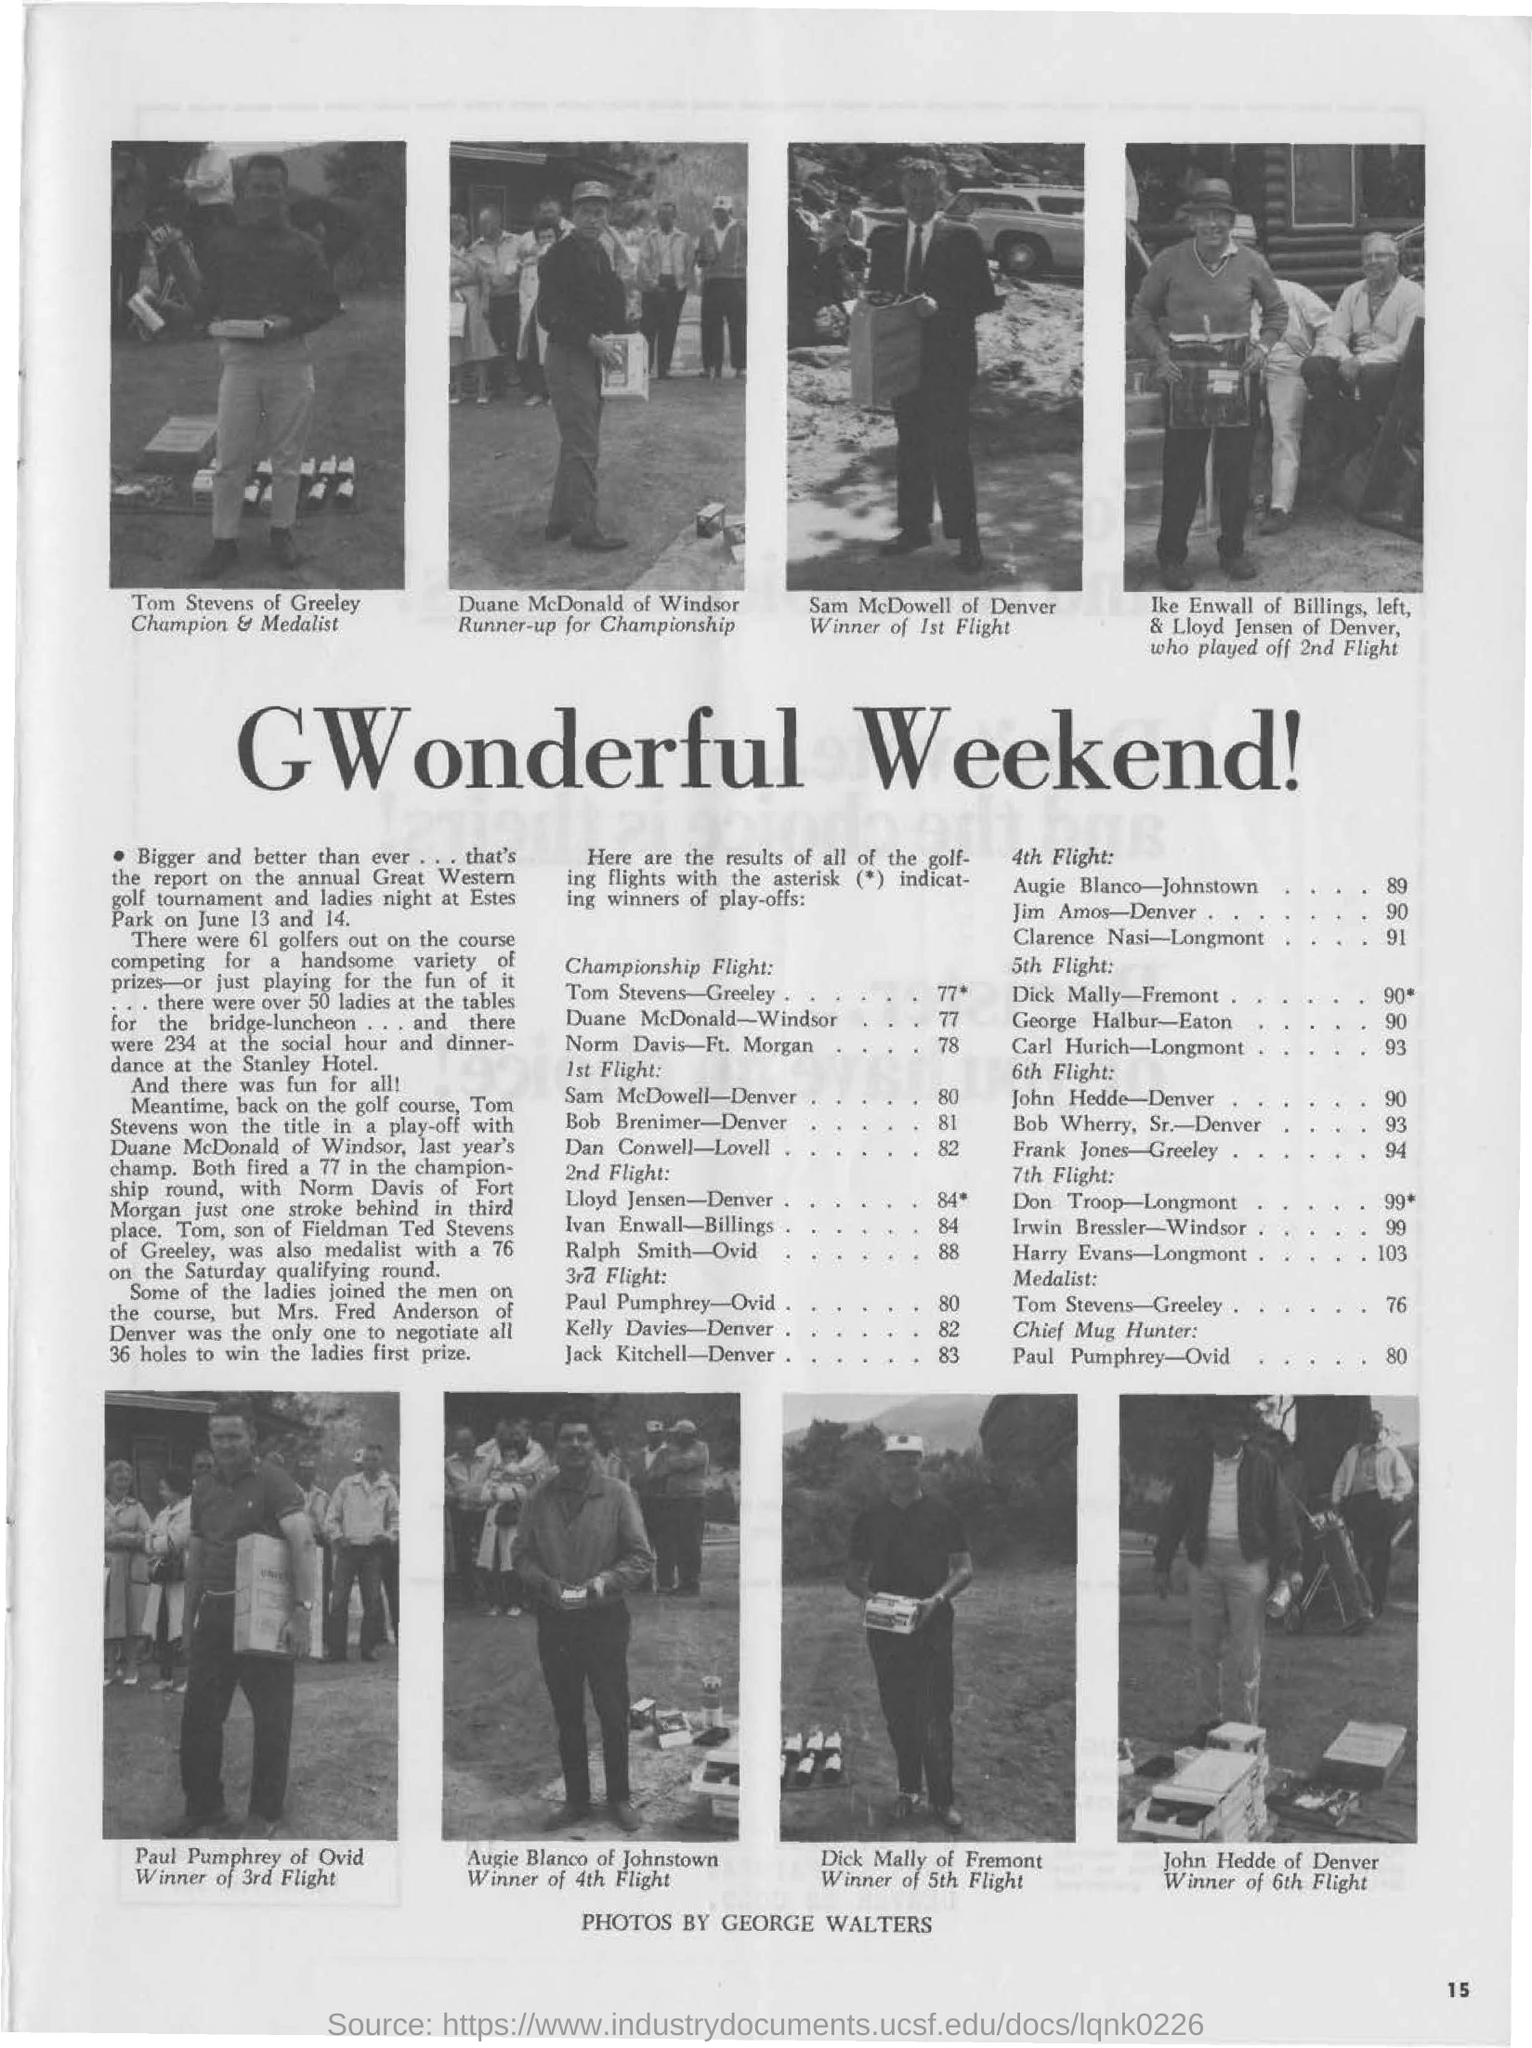What is the title of the document?
Provide a short and direct response. GWonderful Weekend!. Who is the Champion?
Give a very brief answer. Tom Stevens of Greeley. Tom Stevens is from which place?
Give a very brief answer. Greeley. Who is the Winner of 1st Flight?
Provide a short and direct response. Sam McDowell. 